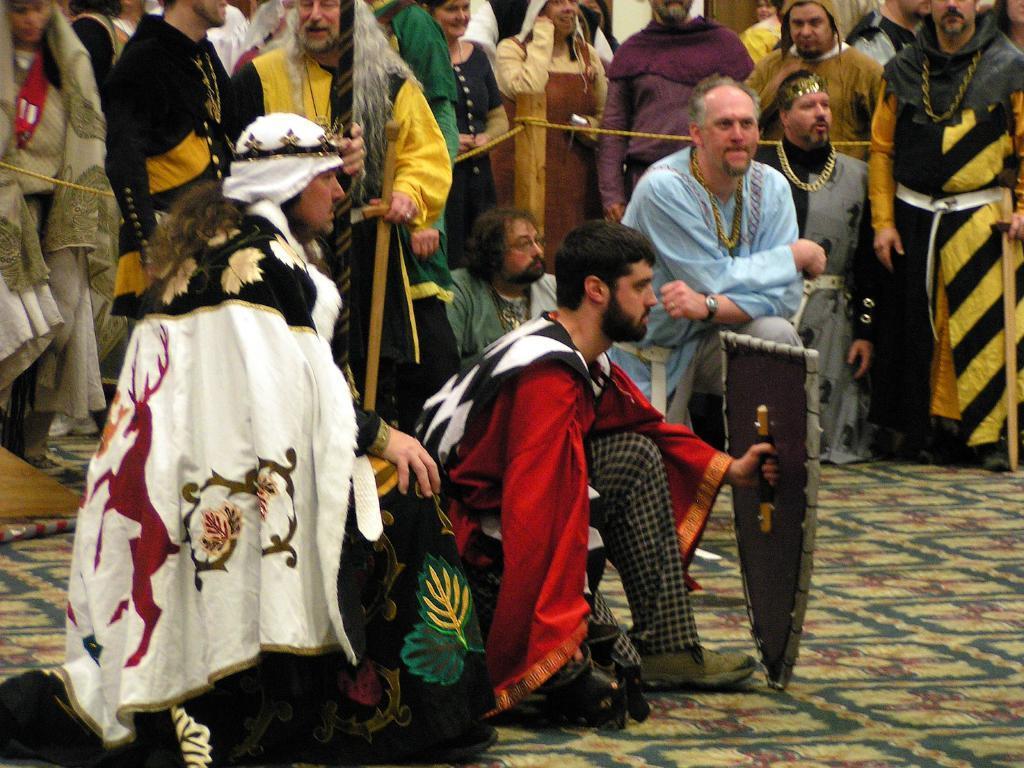Could you give a brief overview of what you see in this image? In this image in front there are people sitting on the mat. Behind them there are few other people. There is a fence in the center of the image. 